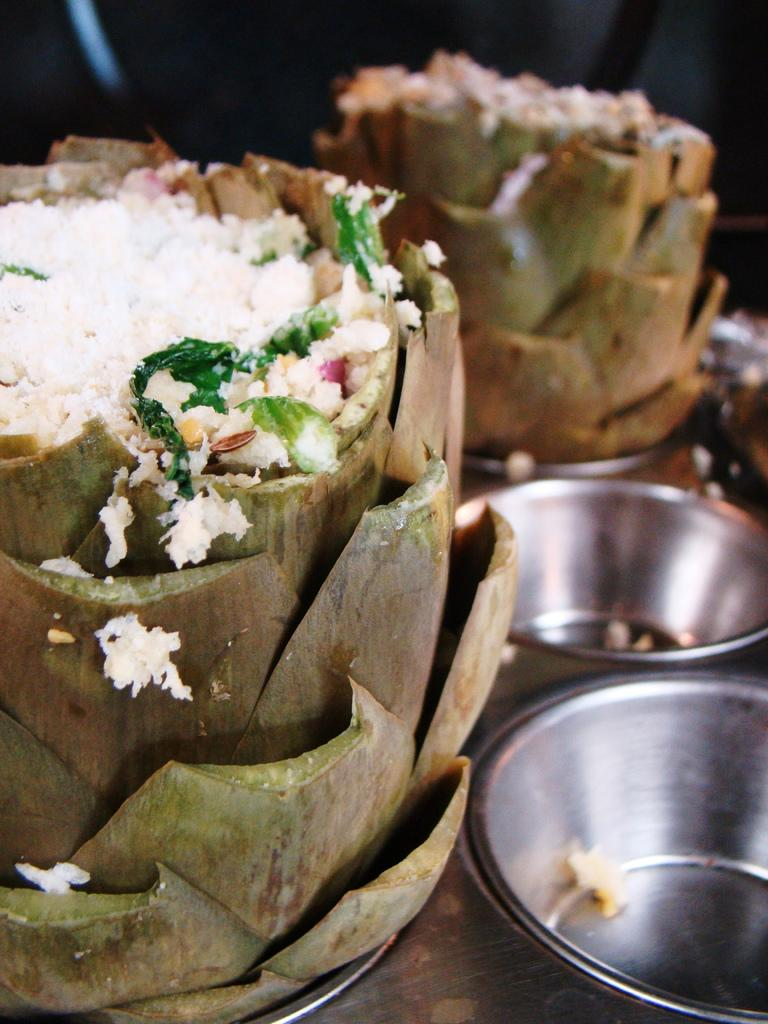What type of food can be seen in the image? The food in the image has a green color. How many bowls are visible in the image? There are bowls in the image. Can you describe the quality of the image? The image is slightly blurry in the background. What type of ship can be seen sailing in the background of the image? There is no ship visible in the image; it only features green food and bowls. How does the acoustics of the room affect the sound of the songs being played in the image? There is no information about songs or acoustics in the image, as it only features green food and bowls. 